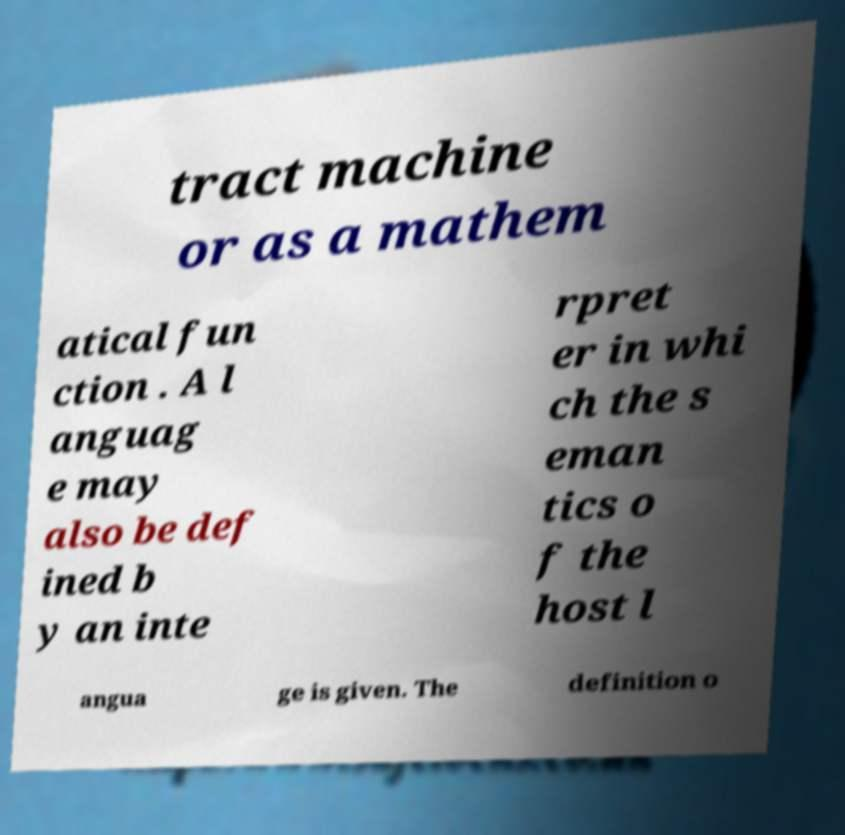Please read and relay the text visible in this image. What does it say? tract machine or as a mathem atical fun ction . A l anguag e may also be def ined b y an inte rpret er in whi ch the s eman tics o f the host l angua ge is given. The definition o 